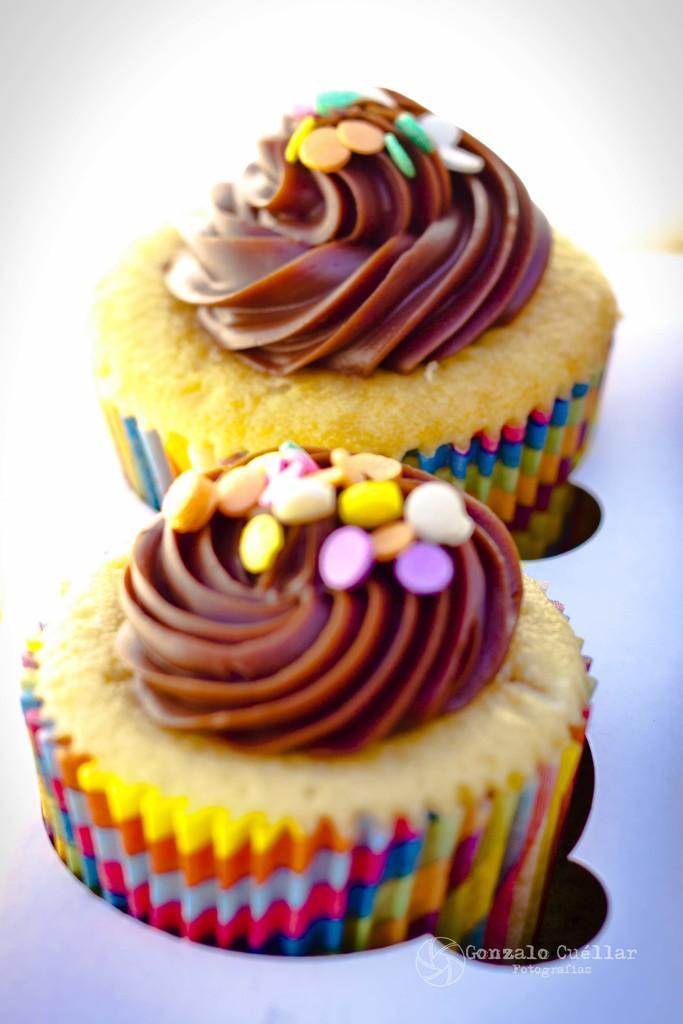How would you summarize this image in a sentence or two? In this image there are cupcakes. 